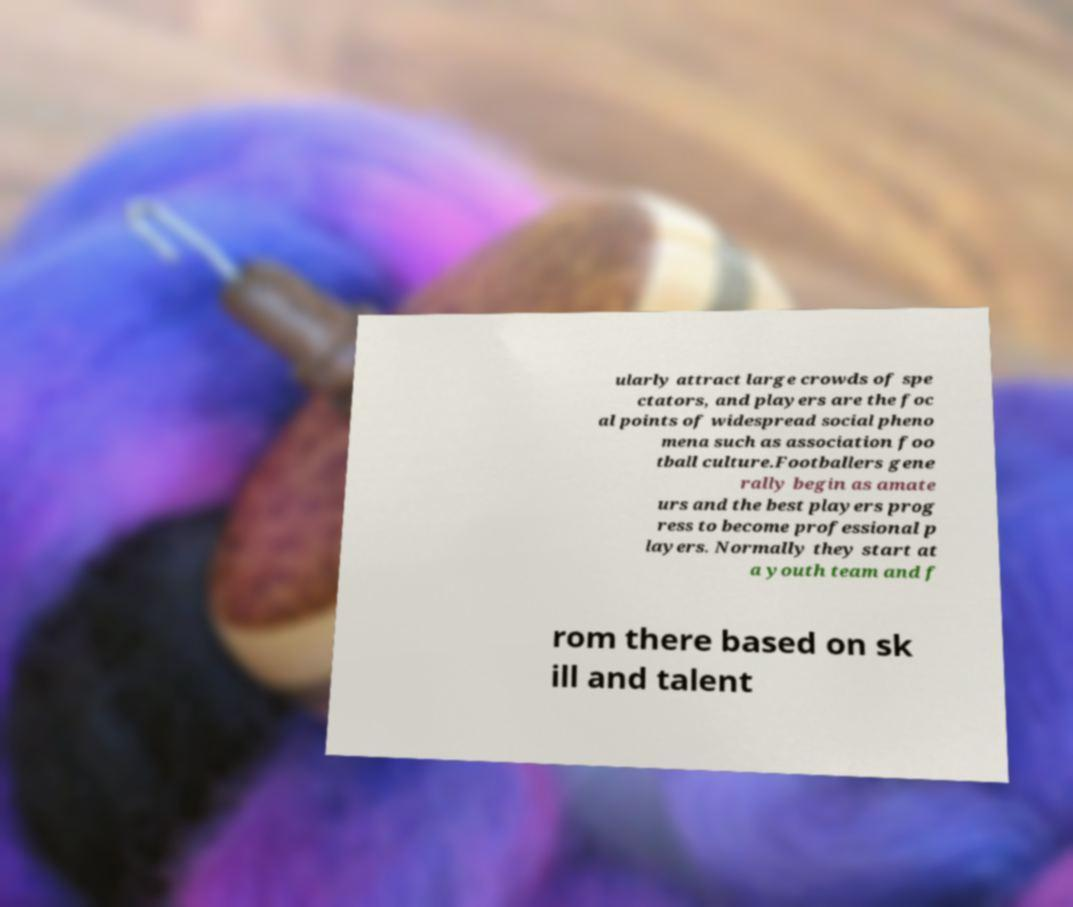There's text embedded in this image that I need extracted. Can you transcribe it verbatim? ularly attract large crowds of spe ctators, and players are the foc al points of widespread social pheno mena such as association foo tball culture.Footballers gene rally begin as amate urs and the best players prog ress to become professional p layers. Normally they start at a youth team and f rom there based on sk ill and talent 